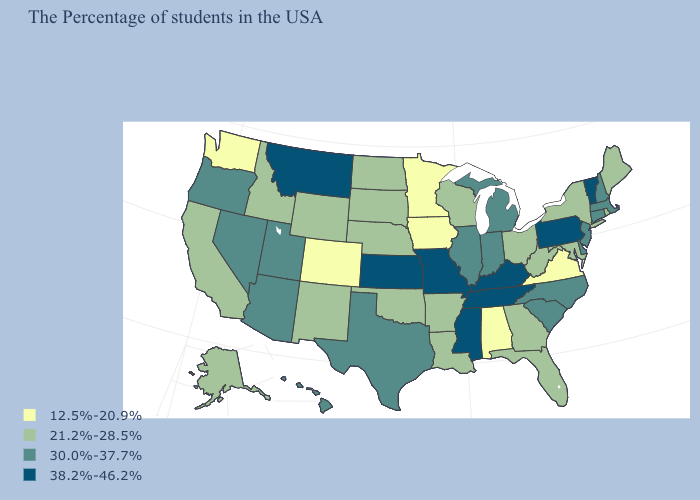How many symbols are there in the legend?
Keep it brief. 4. What is the value of Oklahoma?
Quick response, please. 21.2%-28.5%. Name the states that have a value in the range 12.5%-20.9%?
Short answer required. Virginia, Alabama, Minnesota, Iowa, Colorado, Washington. Does the first symbol in the legend represent the smallest category?
Short answer required. Yes. Which states have the lowest value in the West?
Short answer required. Colorado, Washington. What is the value of Arkansas?
Be succinct. 21.2%-28.5%. Does Virginia have the highest value in the USA?
Concise answer only. No. Does Kentucky have the lowest value in the USA?
Short answer required. No. Which states have the lowest value in the USA?
Give a very brief answer. Virginia, Alabama, Minnesota, Iowa, Colorado, Washington. Does the first symbol in the legend represent the smallest category?
Answer briefly. Yes. What is the lowest value in the USA?
Quick response, please. 12.5%-20.9%. Does California have a higher value than Washington?
Short answer required. Yes. What is the value of Arkansas?
Keep it brief. 21.2%-28.5%. Does the map have missing data?
Short answer required. No. What is the highest value in the South ?
Quick response, please. 38.2%-46.2%. 